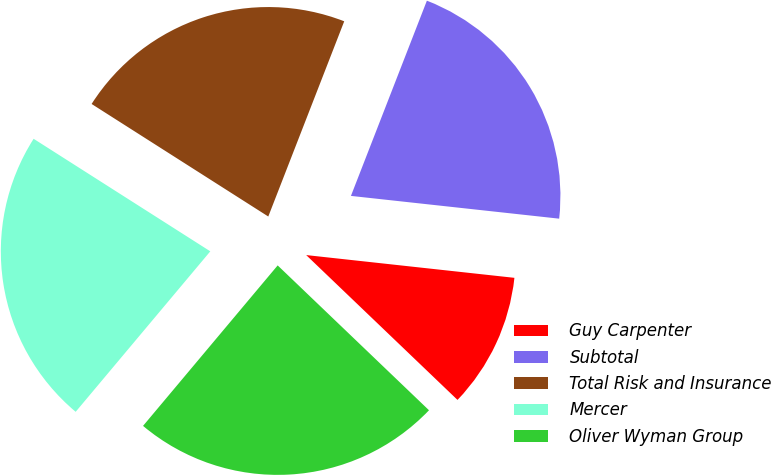<chart> <loc_0><loc_0><loc_500><loc_500><pie_chart><fcel>Guy Carpenter<fcel>Subtotal<fcel>Total Risk and Insurance<fcel>Mercer<fcel>Oliver Wyman Group<nl><fcel>10.42%<fcel>20.83%<fcel>21.88%<fcel>22.92%<fcel>23.96%<nl></chart> 